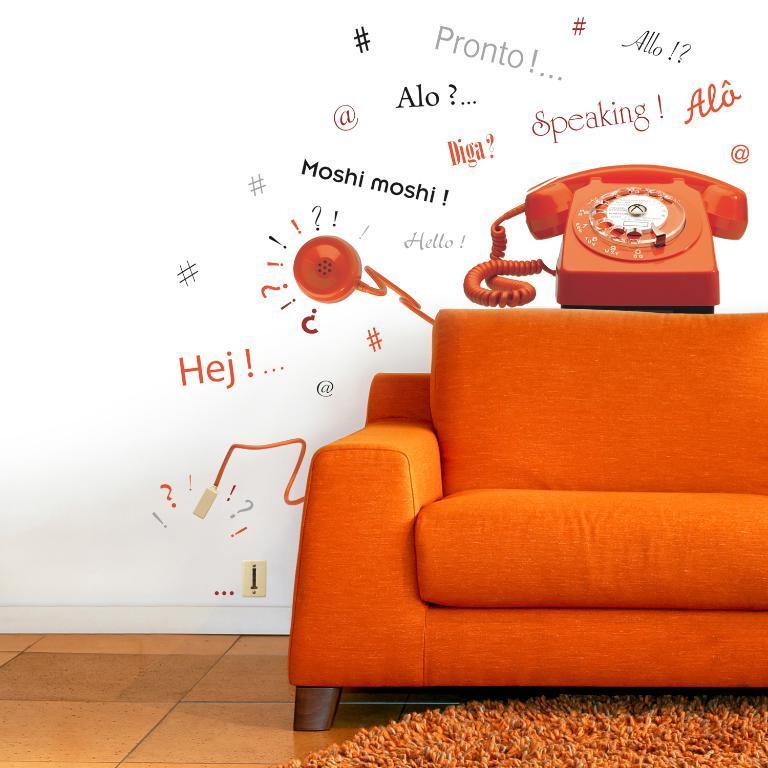Please provide a concise description of this image. in the image there is a orange sofa on it there is a phone. There is an orange carpet on the floor. The wall is white in color. In the wall there are many text. 